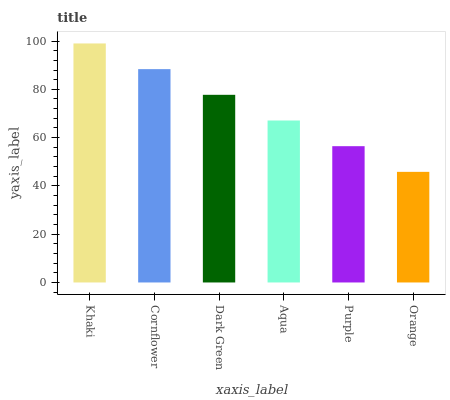Is Orange the minimum?
Answer yes or no. Yes. Is Khaki the maximum?
Answer yes or no. Yes. Is Cornflower the minimum?
Answer yes or no. No. Is Cornflower the maximum?
Answer yes or no. No. Is Khaki greater than Cornflower?
Answer yes or no. Yes. Is Cornflower less than Khaki?
Answer yes or no. Yes. Is Cornflower greater than Khaki?
Answer yes or no. No. Is Khaki less than Cornflower?
Answer yes or no. No. Is Dark Green the high median?
Answer yes or no. Yes. Is Aqua the low median?
Answer yes or no. Yes. Is Khaki the high median?
Answer yes or no. No. Is Purple the low median?
Answer yes or no. No. 